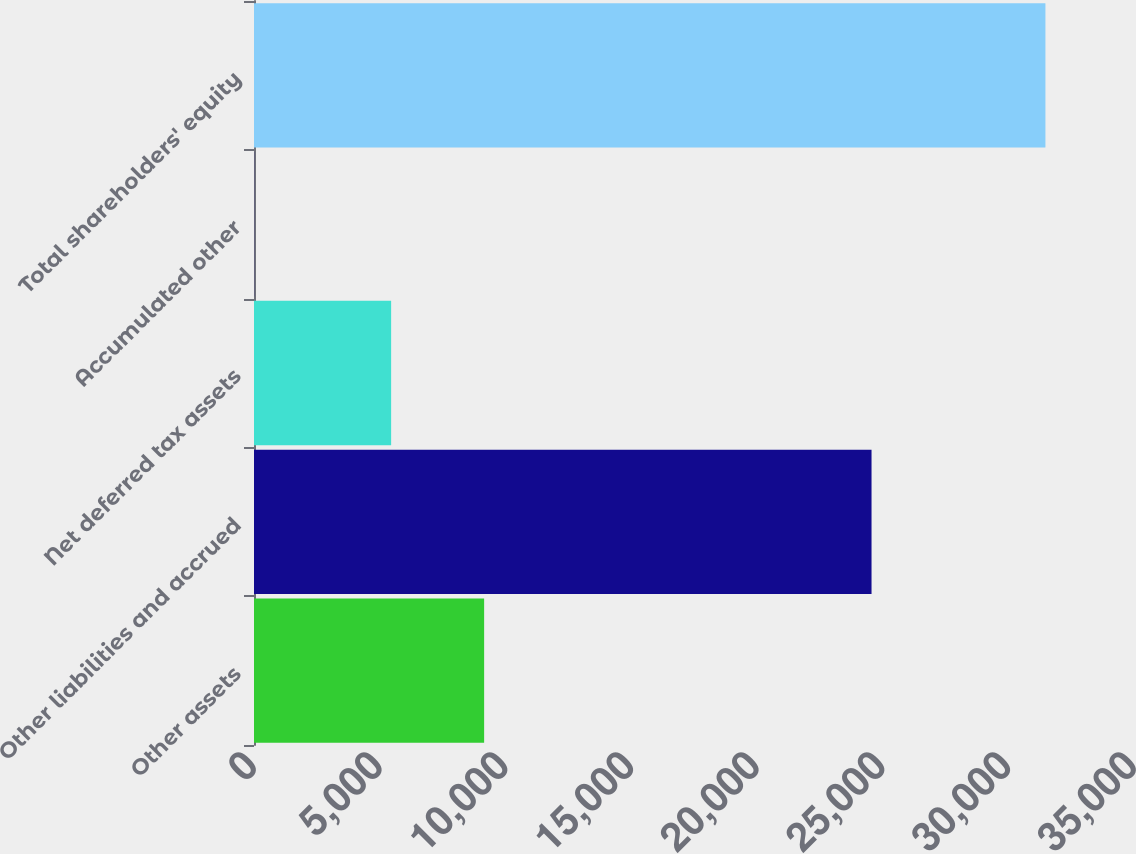Convert chart to OTSL. <chart><loc_0><loc_0><loc_500><loc_500><bar_chart><fcel>Other assets<fcel>Other liabilities and accrued<fcel>Net deferred tax assets<fcel>Accumulated other<fcel>Total shareholders' equity<nl><fcel>9153<fcel>24561<fcel>5454<fcel>9<fcel>31477<nl></chart> 